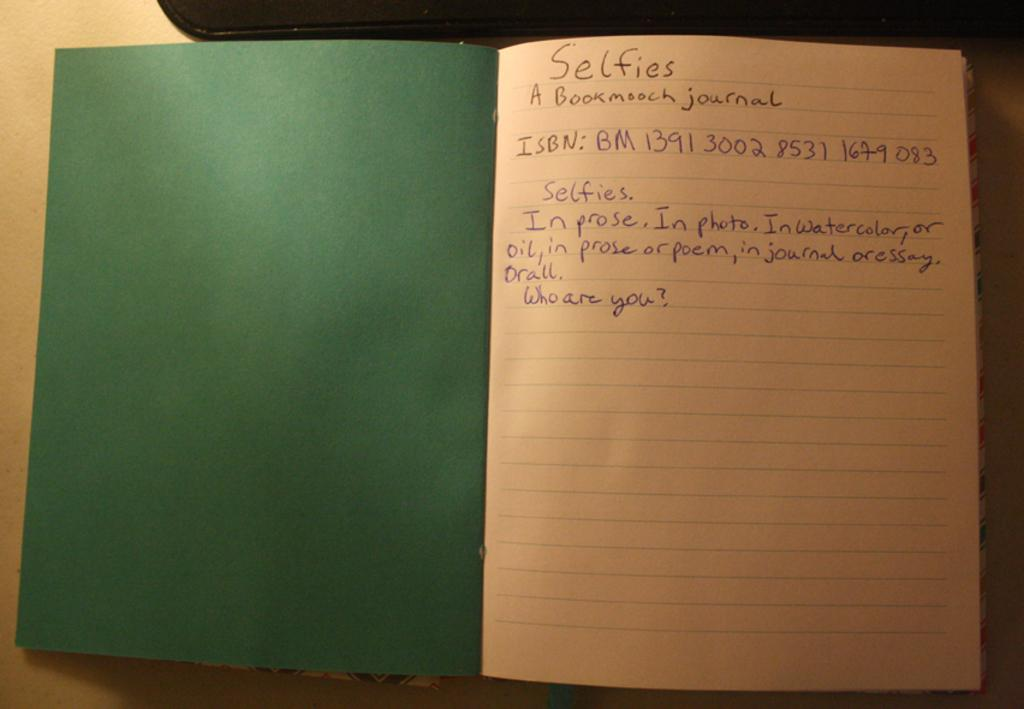What is the main object in the image? There is a book in the image. What is the color of the second object in the image? There is a black color object in the image. What is the color of the surface on which both objects are placed? Both the book and the black color object are on a cream color surface. How many examples of skirts can be seen in the image? There are no skirts present in the image. What is the amount of information provided in the image? The image provides information about a book and a black color object on a cream color surface, but it does not convey any specific amount of information. 